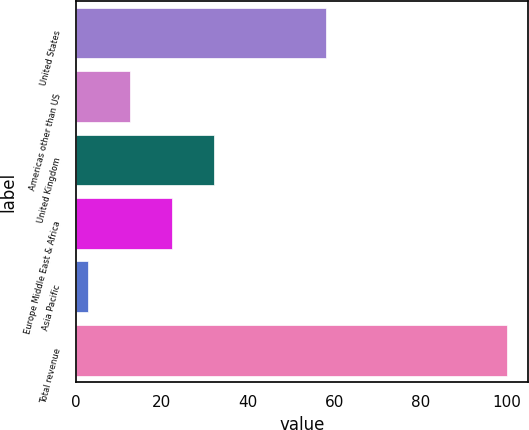Convert chart. <chart><loc_0><loc_0><loc_500><loc_500><bar_chart><fcel>United States<fcel>Americas other than US<fcel>United Kingdom<fcel>Europe Middle East & Africa<fcel>Asia Pacific<fcel>Total revenue<nl><fcel>58<fcel>12.7<fcel>32.1<fcel>22.4<fcel>3<fcel>100<nl></chart> 